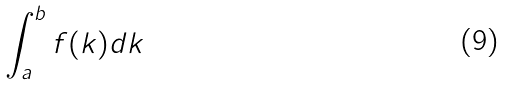Convert formula to latex. <formula><loc_0><loc_0><loc_500><loc_500>\int _ { a } ^ { b } f ( k ) d k</formula> 